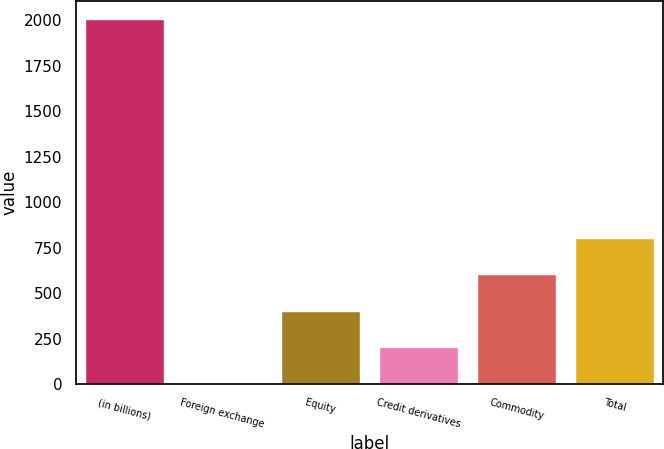Convert chart to OTSL. <chart><loc_0><loc_0><loc_500><loc_500><bar_chart><fcel>(in billions)<fcel>Foreign exchange<fcel>Equity<fcel>Credit derivatives<fcel>Commodity<fcel>Total<nl><fcel>2005<fcel>3<fcel>403.4<fcel>203.2<fcel>603.6<fcel>803.8<nl></chart> 